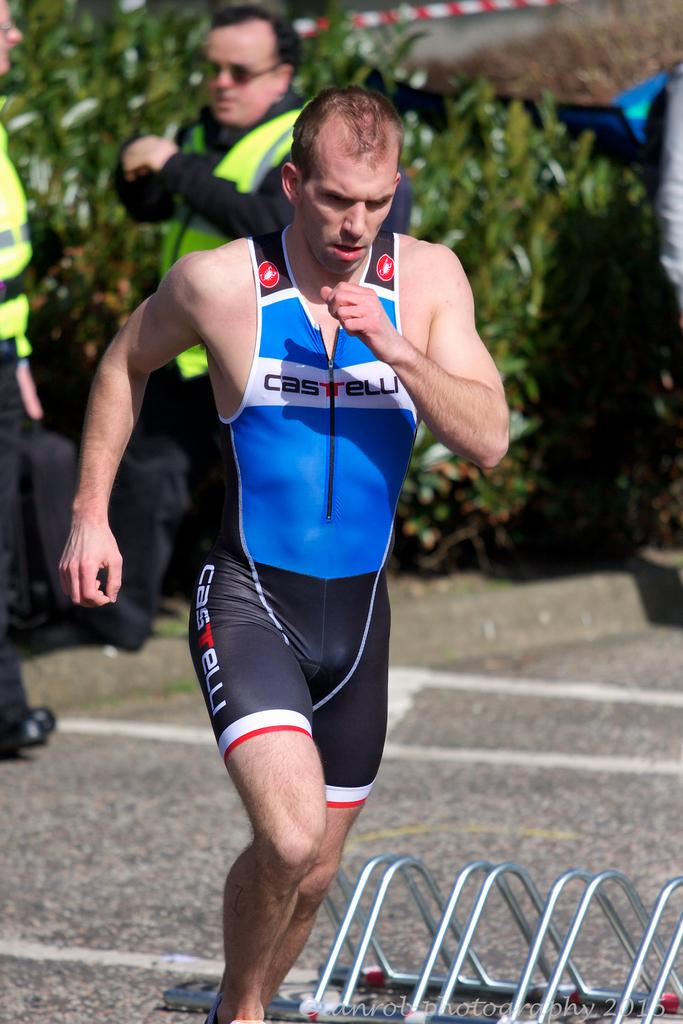What is located in the foreground of the image? There is a person, an iron frame, and a rock surface in the foreground of the image. What can be seen in the background of the image? There are plants, people, and other objects in the background of the image. What type of surface is the person standing on in the foreground? The person is standing on a rock surface in the foreground. Can you describe the iron frame in the foreground? The iron frame in the foreground is a structure with a specific shape or design. How many stems are visible in the image? There is no mention of stems in the provided facts, so it is impossible to determine the number of stems in the image. 